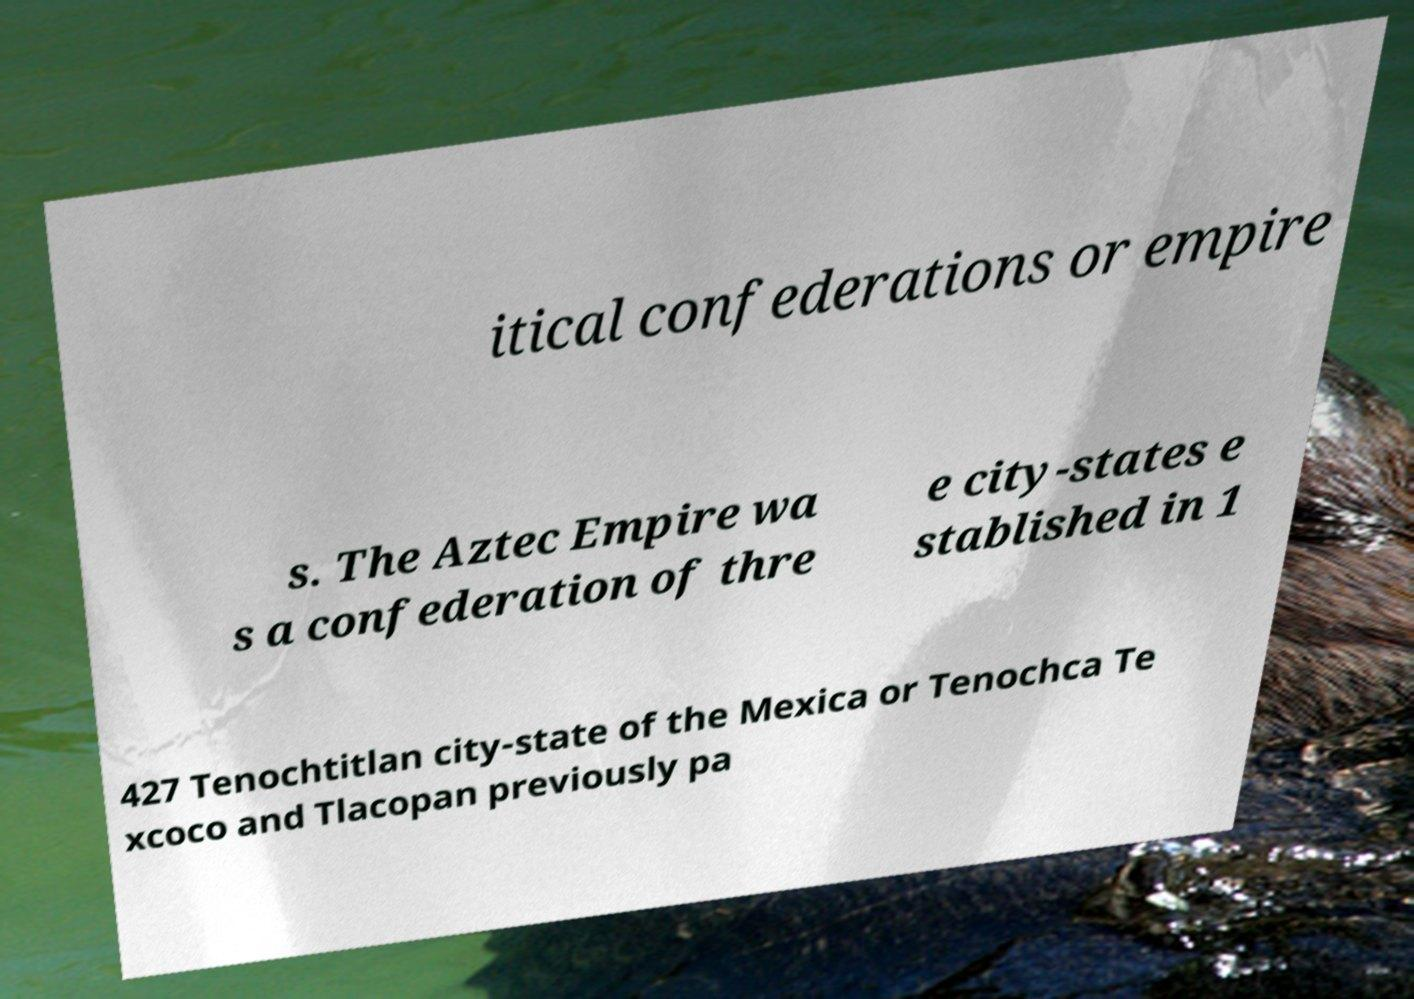Could you assist in decoding the text presented in this image and type it out clearly? itical confederations or empire s. The Aztec Empire wa s a confederation of thre e city-states e stablished in 1 427 Tenochtitlan city-state of the Mexica or Tenochca Te xcoco and Tlacopan previously pa 